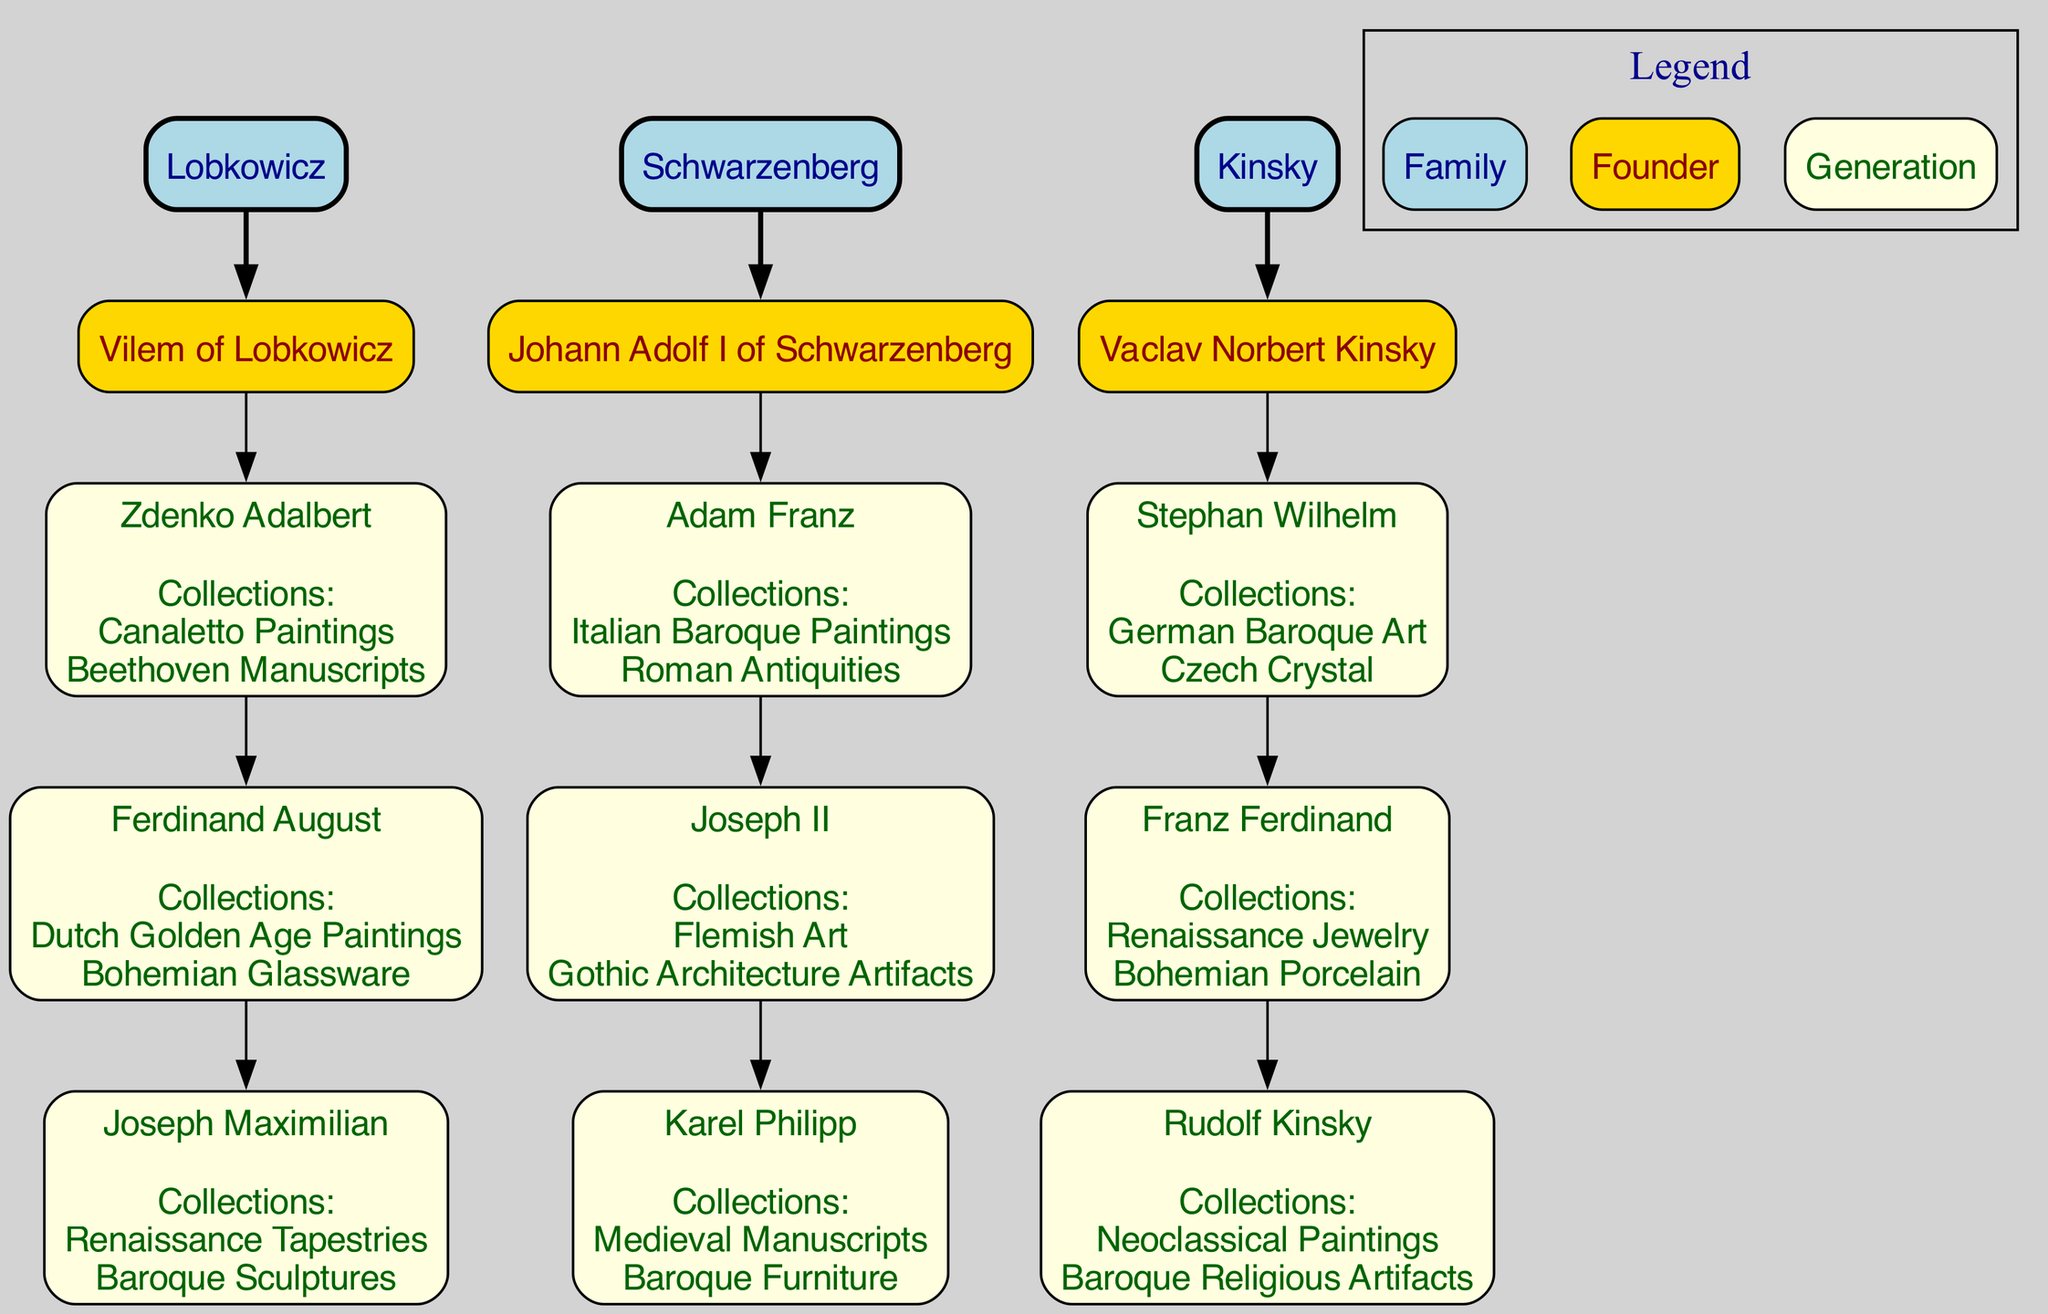What is the name of the founder of the Lobkowicz family? The founder of the Lobkowicz family, as indicated in the diagram, is displayed clearly under the family node, labeled "Vilem of Lobkowicz."
Answer: Vilem of Lobkowicz How many generations are represented in the Schwarzenberg family? By counting the nodes connected to the founder "Johann Adolf I of Schwarzenberg," there are three generations listed: Adam Franz, Joseph II, and Karel Philipp.
Answer: 3 What notable collection is associated with Zdenko Adalbert of the Lobkowicz family? The collections are listed under the node for Zdenko Adalbert, which specifically mentions "Canaletto Paintings" and "Beethoven Manuscripts."
Answer: Canaletto Paintings, Beethoven Manuscripts Which family has an heir named Rudolf Kinsky? The diagram shows that Rudolf Kinsky is a descendant of the Kinsky family, specifically listed as the last generation.
Answer: Kinsky What type of art is common among the collections of the Kinsky family? Looking at the notable collections listed under the three generations of Kinsky, the common types include "Baroque Religious Artifacts" and "German Baroque Art."
Answer: Baroque Art Who has the collection of Italian Baroque Paintings? To find the answer, check the node for Adam Franz, who is specifically noted for having "Italian Baroque Paintings" in his collections.
Answer: Adam Franz Which family is associated with the founder Johann Adolf I? The family connected to the founder Johann Adolf I is clearly labeled in the diagram, which corresponds to the "Schwarzenberg" family node.
Answer: Schwarzenberg Count the total number of notable collections listed for all generations in the Lobkowicz family. By reviewing the notable collections listed under each member, you find that Zdenko Adalbert has two, Ferdinand August has two, and Joseph Maximilian has two, totaling six collections overall.
Answer: 6 